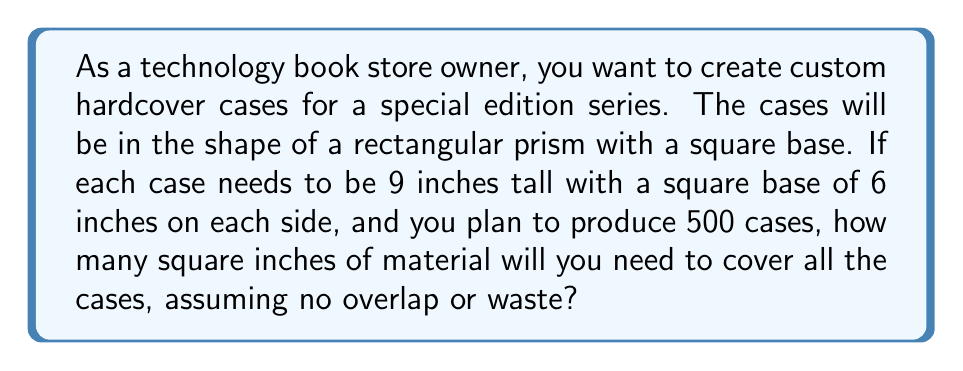What is the answer to this math problem? Let's approach this step-by-step:

1) First, we need to calculate the surface area of one case. A rectangular prism has 6 faces: top, bottom, front, back, left, and right.

2) The top and bottom are squares with side length 6 inches. The area of each is:
   $$A_{top} = A_{bottom} = 6^2 = 36 \text{ sq inches}$$

3) The front, back, left, and right faces are all rectangles. They have a width of 6 inches and a height of 9 inches. The area of each is:
   $$A_{side} = 6 * 9 = 54 \text{ sq inches}$$

4) The total surface area of one case is:
   $$SA_{case} = 2A_{top} + 4A_{side} = 2(36) + 4(54) = 72 + 216 = 288 \text{ sq inches}$$

5) For 500 cases, we multiply this by 500:
   $$SA_{total} = 500 * 288 = 144,000 \text{ sq inches}$$

Therefore, you will need 144,000 square inches of material to cover all 500 cases.
Answer: 144,000 square inches 